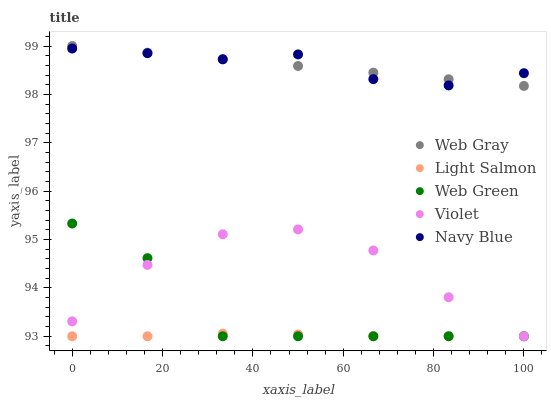Does Light Salmon have the minimum area under the curve?
Answer yes or no. Yes. Does Navy Blue have the maximum area under the curve?
Answer yes or no. Yes. Does Web Gray have the minimum area under the curve?
Answer yes or no. No. Does Web Gray have the maximum area under the curve?
Answer yes or no. No. Is Web Gray the smoothest?
Answer yes or no. Yes. Is Web Green the roughest?
Answer yes or no. Yes. Is Light Salmon the smoothest?
Answer yes or no. No. Is Light Salmon the roughest?
Answer yes or no. No. Does Light Salmon have the lowest value?
Answer yes or no. Yes. Does Web Gray have the lowest value?
Answer yes or no. No. Does Web Gray have the highest value?
Answer yes or no. Yes. Does Light Salmon have the highest value?
Answer yes or no. No. Is Web Green less than Web Gray?
Answer yes or no. Yes. Is Navy Blue greater than Web Green?
Answer yes or no. Yes. Does Web Green intersect Light Salmon?
Answer yes or no. Yes. Is Web Green less than Light Salmon?
Answer yes or no. No. Is Web Green greater than Light Salmon?
Answer yes or no. No. Does Web Green intersect Web Gray?
Answer yes or no. No. 